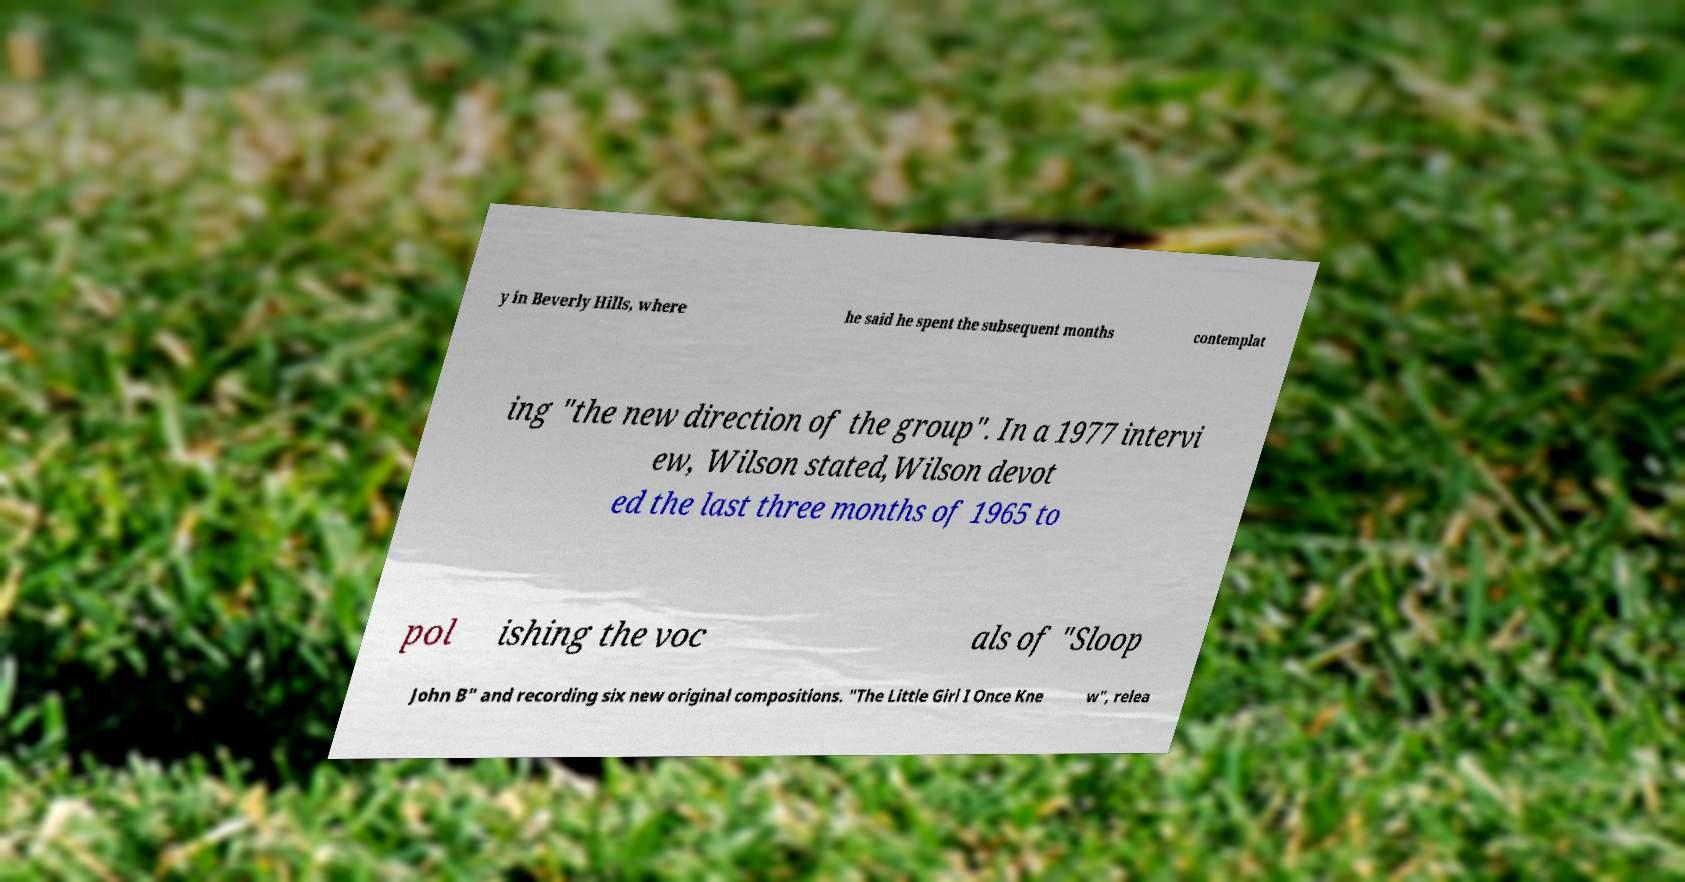I need the written content from this picture converted into text. Can you do that? y in Beverly Hills, where he said he spent the subsequent months contemplat ing "the new direction of the group". In a 1977 intervi ew, Wilson stated,Wilson devot ed the last three months of 1965 to pol ishing the voc als of "Sloop John B" and recording six new original compositions. "The Little Girl I Once Kne w", relea 